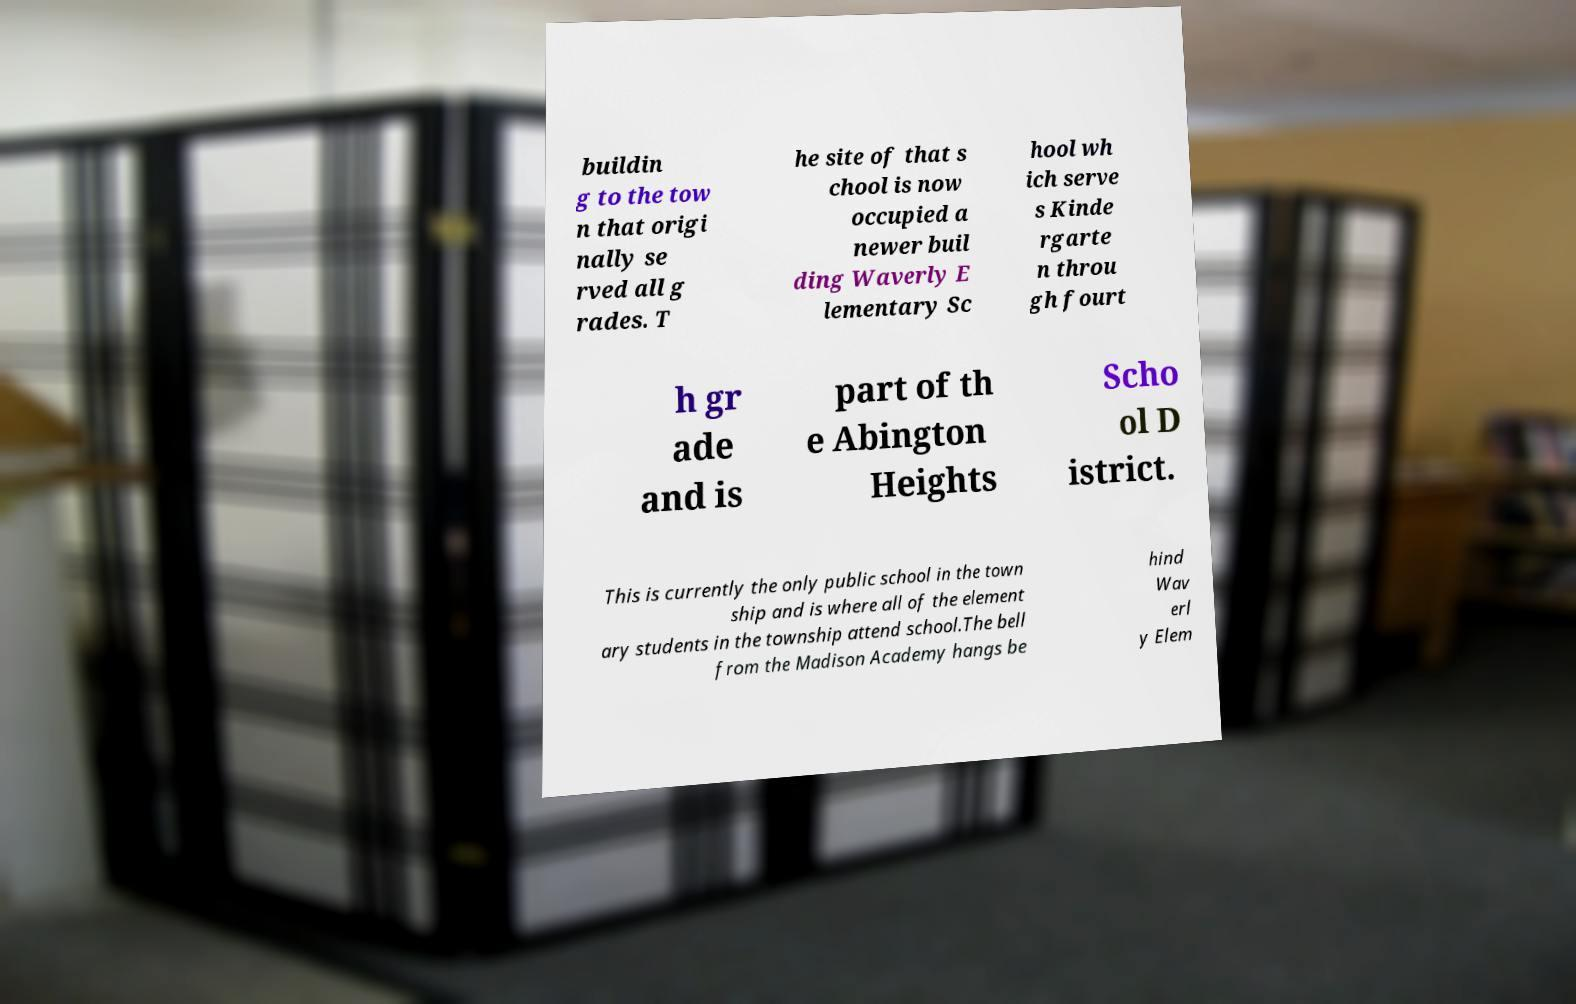Can you accurately transcribe the text from the provided image for me? buildin g to the tow n that origi nally se rved all g rades. T he site of that s chool is now occupied a newer buil ding Waverly E lementary Sc hool wh ich serve s Kinde rgarte n throu gh fourt h gr ade and is part of th e Abington Heights Scho ol D istrict. This is currently the only public school in the town ship and is where all of the element ary students in the township attend school.The bell from the Madison Academy hangs be hind Wav erl y Elem 